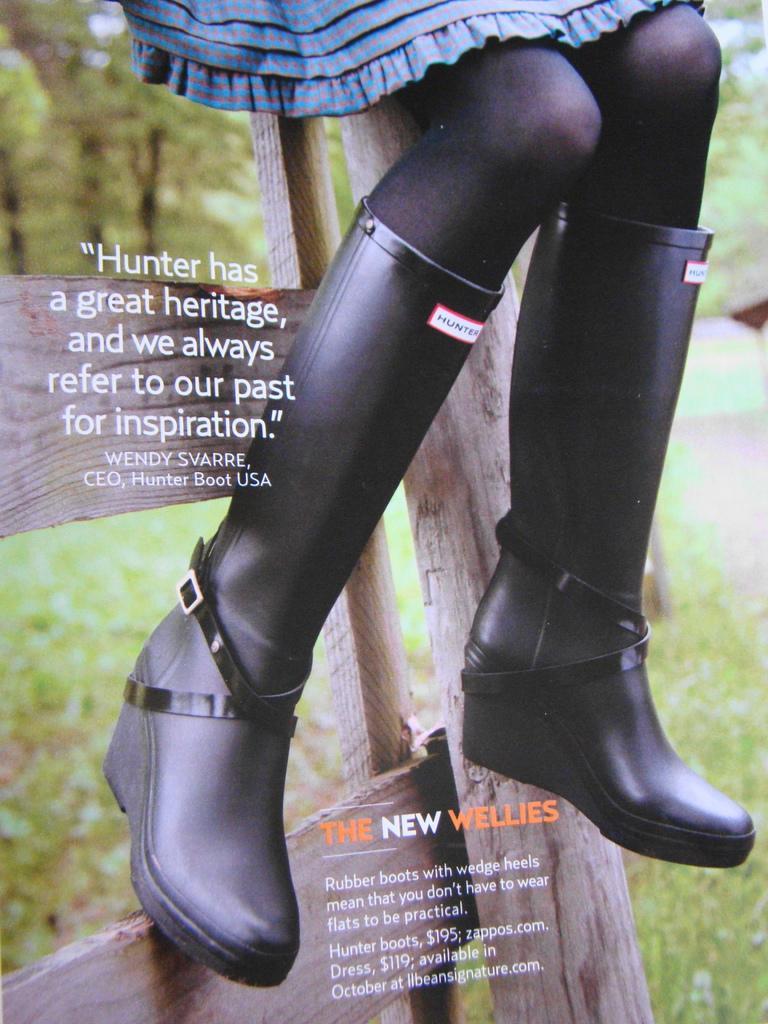Can you describe this image briefly? In this image it seems like it is a cover page of the magazine in which there is a person sitting on the wooden stick by keeping her legs on the wooden stick. We can see that there are boots to her legs. 